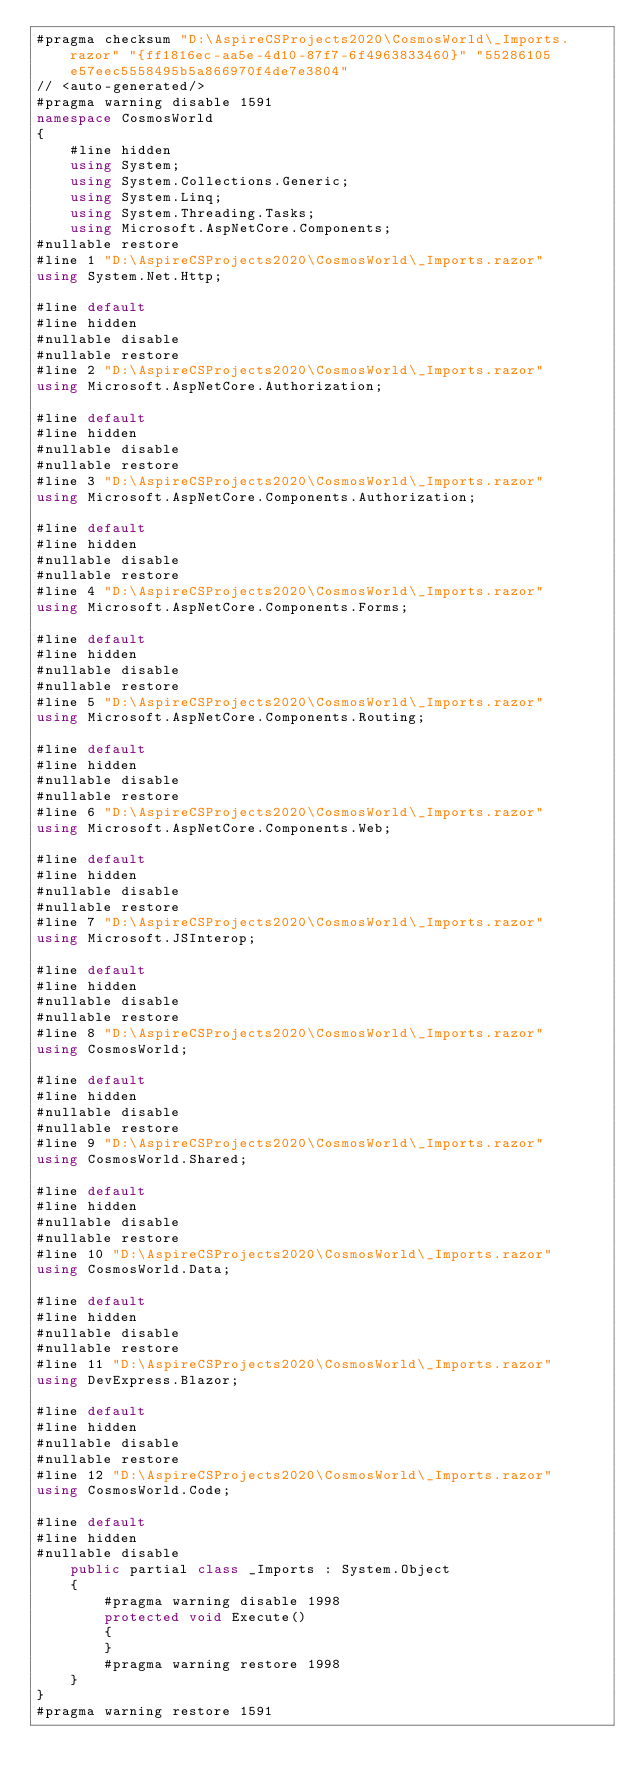Convert code to text. <code><loc_0><loc_0><loc_500><loc_500><_C#_>#pragma checksum "D:\AspireCSProjects2020\CosmosWorld\_Imports.razor" "{ff1816ec-aa5e-4d10-87f7-6f4963833460}" "55286105e57eec5558495b5a866970f4de7e3804"
// <auto-generated/>
#pragma warning disable 1591
namespace CosmosWorld
{
    #line hidden
    using System;
    using System.Collections.Generic;
    using System.Linq;
    using System.Threading.Tasks;
    using Microsoft.AspNetCore.Components;
#nullable restore
#line 1 "D:\AspireCSProjects2020\CosmosWorld\_Imports.razor"
using System.Net.Http;

#line default
#line hidden
#nullable disable
#nullable restore
#line 2 "D:\AspireCSProjects2020\CosmosWorld\_Imports.razor"
using Microsoft.AspNetCore.Authorization;

#line default
#line hidden
#nullable disable
#nullable restore
#line 3 "D:\AspireCSProjects2020\CosmosWorld\_Imports.razor"
using Microsoft.AspNetCore.Components.Authorization;

#line default
#line hidden
#nullable disable
#nullable restore
#line 4 "D:\AspireCSProjects2020\CosmosWorld\_Imports.razor"
using Microsoft.AspNetCore.Components.Forms;

#line default
#line hidden
#nullable disable
#nullable restore
#line 5 "D:\AspireCSProjects2020\CosmosWorld\_Imports.razor"
using Microsoft.AspNetCore.Components.Routing;

#line default
#line hidden
#nullable disable
#nullable restore
#line 6 "D:\AspireCSProjects2020\CosmosWorld\_Imports.razor"
using Microsoft.AspNetCore.Components.Web;

#line default
#line hidden
#nullable disable
#nullable restore
#line 7 "D:\AspireCSProjects2020\CosmosWorld\_Imports.razor"
using Microsoft.JSInterop;

#line default
#line hidden
#nullable disable
#nullable restore
#line 8 "D:\AspireCSProjects2020\CosmosWorld\_Imports.razor"
using CosmosWorld;

#line default
#line hidden
#nullable disable
#nullable restore
#line 9 "D:\AspireCSProjects2020\CosmosWorld\_Imports.razor"
using CosmosWorld.Shared;

#line default
#line hidden
#nullable disable
#nullable restore
#line 10 "D:\AspireCSProjects2020\CosmosWorld\_Imports.razor"
using CosmosWorld.Data;

#line default
#line hidden
#nullable disable
#nullable restore
#line 11 "D:\AspireCSProjects2020\CosmosWorld\_Imports.razor"
using DevExpress.Blazor;

#line default
#line hidden
#nullable disable
#nullable restore
#line 12 "D:\AspireCSProjects2020\CosmosWorld\_Imports.razor"
using CosmosWorld.Code;

#line default
#line hidden
#nullable disable
    public partial class _Imports : System.Object
    {
        #pragma warning disable 1998
        protected void Execute()
        {
        }
        #pragma warning restore 1998
    }
}
#pragma warning restore 1591
</code> 